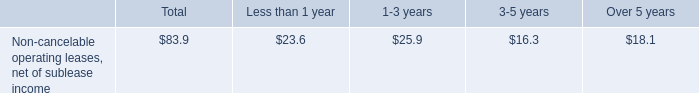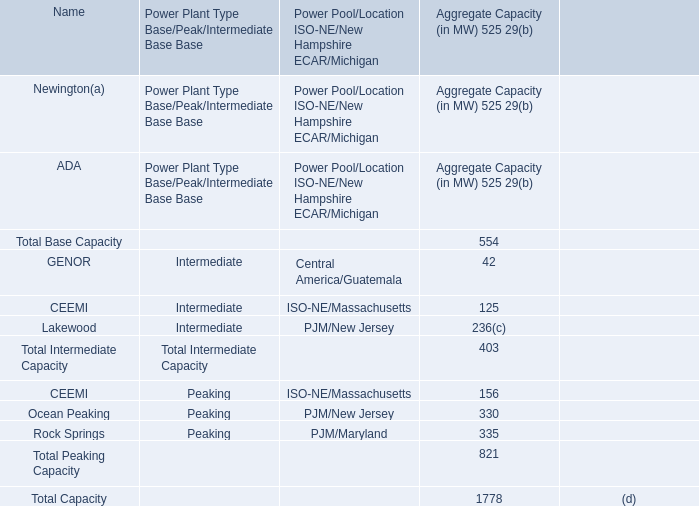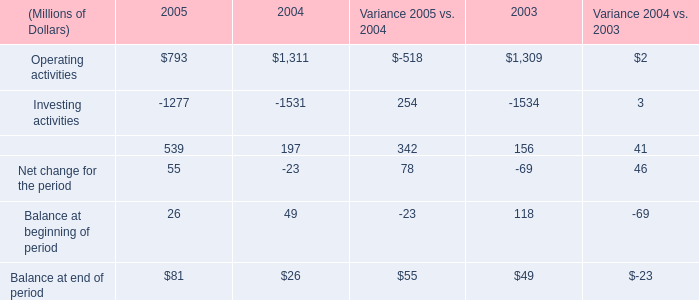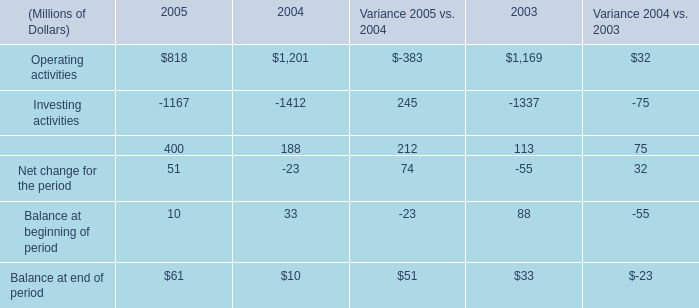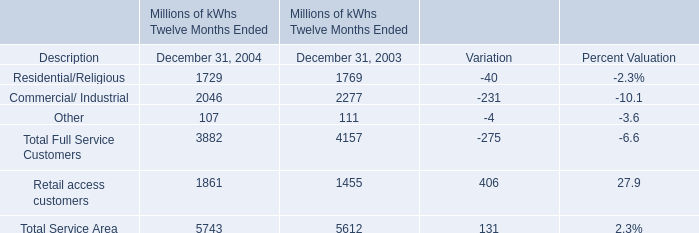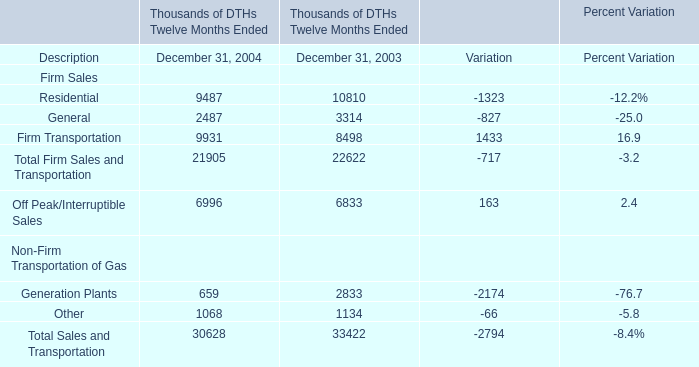In the year with lowest amount of Residential/Religious, what's the increasing rate of Total Service Area? 
Computations: ((5743 - 5612) / 5612)
Answer: 0.02334. 